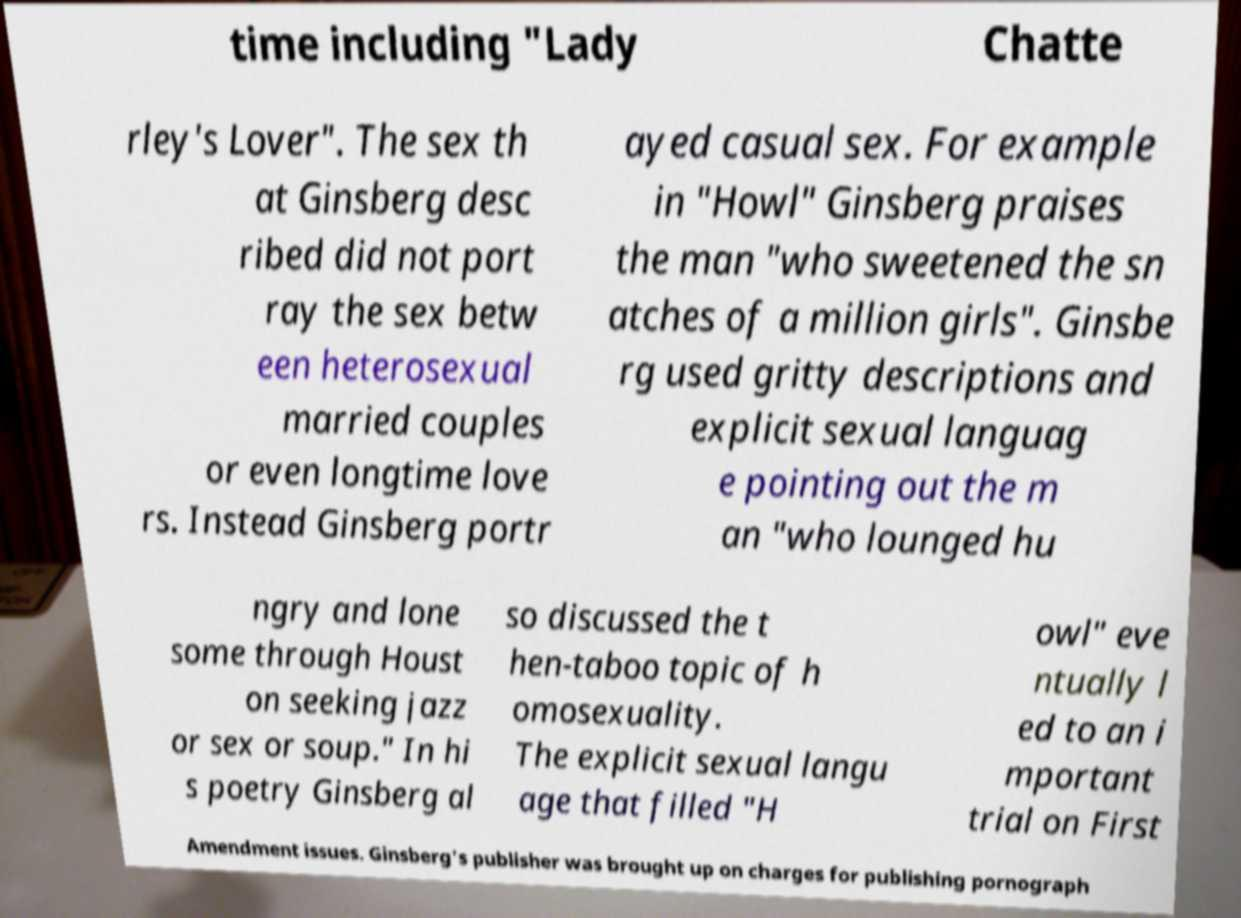Please read and relay the text visible in this image. What does it say? time including "Lady Chatte rley's Lover". The sex th at Ginsberg desc ribed did not port ray the sex betw een heterosexual married couples or even longtime love rs. Instead Ginsberg portr ayed casual sex. For example in "Howl" Ginsberg praises the man "who sweetened the sn atches of a million girls". Ginsbe rg used gritty descriptions and explicit sexual languag e pointing out the m an "who lounged hu ngry and lone some through Houst on seeking jazz or sex or soup." In hi s poetry Ginsberg al so discussed the t hen-taboo topic of h omosexuality. The explicit sexual langu age that filled "H owl" eve ntually l ed to an i mportant trial on First Amendment issues. Ginsberg's publisher was brought up on charges for publishing pornograph 